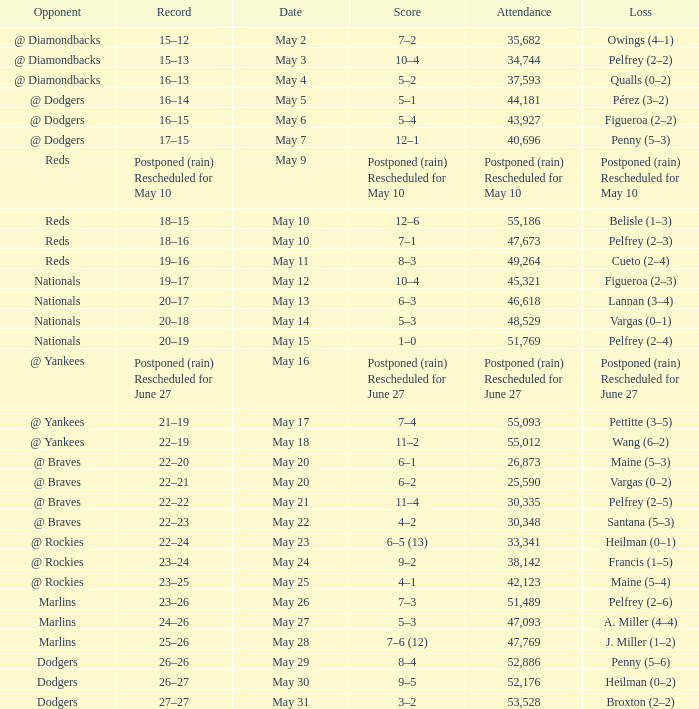Attendance of 30,335 had what record? 22–22. 